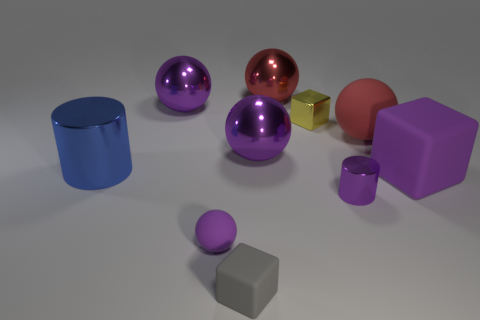Can you tell which objects appear to be of similar material based on their surface texture? In the image, the objects that have a reflective, shiny surface texture are likely made of a similar material, which appears to be metallic or plastic. The two purple spheres and the cylinder share this attribute, suggesting similarity in material. The pink sphere also has a reflective quality but with a slightly muted sheen, which might suggest a different kind of finish on a similar material. 